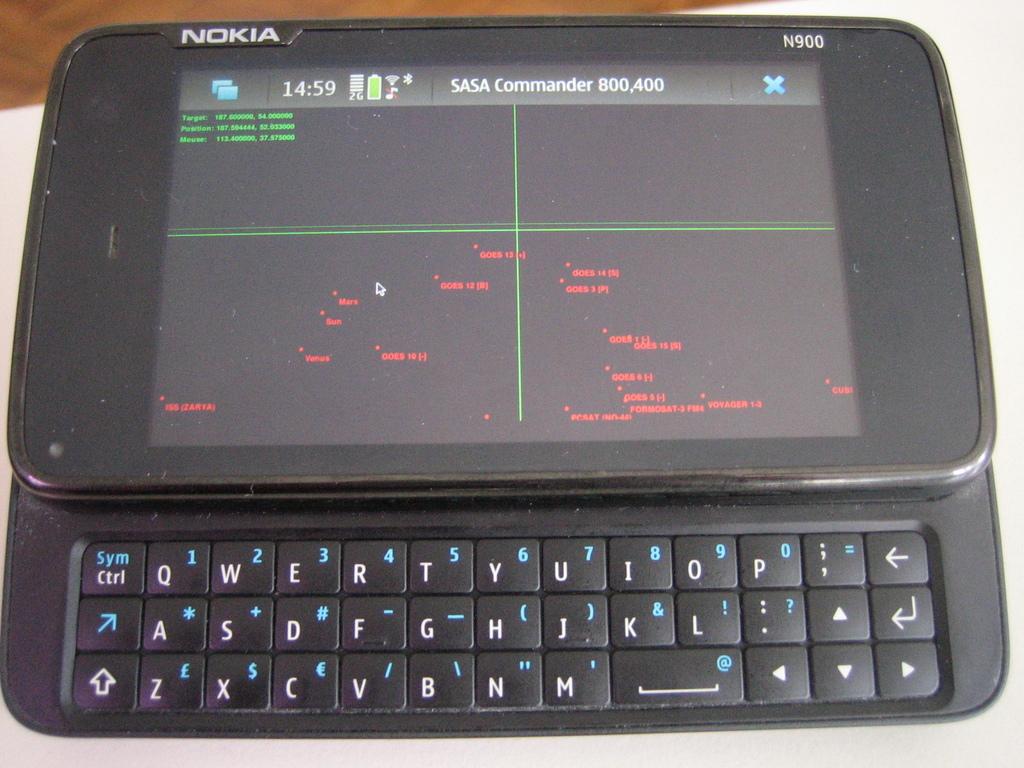What brand of phone is this?
Provide a succinct answer. Nokia. 